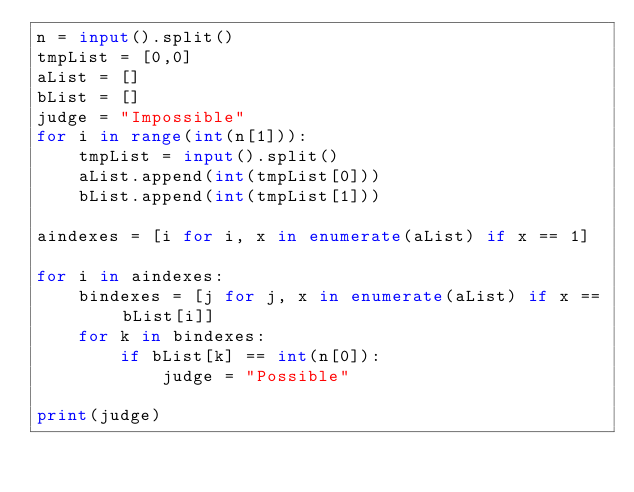Convert code to text. <code><loc_0><loc_0><loc_500><loc_500><_Python_>n = input().split()
tmpList = [0,0]
aList = []
bList = []
judge = "Impossible"
for i in range(int(n[1])):
    tmpList = input().split()
    aList.append(int(tmpList[0]))
    bList.append(int(tmpList[1]))

aindexes = [i for i, x in enumerate(aList) if x == 1]

for i in aindexes:
    bindexes = [j for j, x in enumerate(aList) if x == bList[i]]
    for k in bindexes:
        if bList[k] == int(n[0]):
            judge = "Possible"

print(judge)</code> 